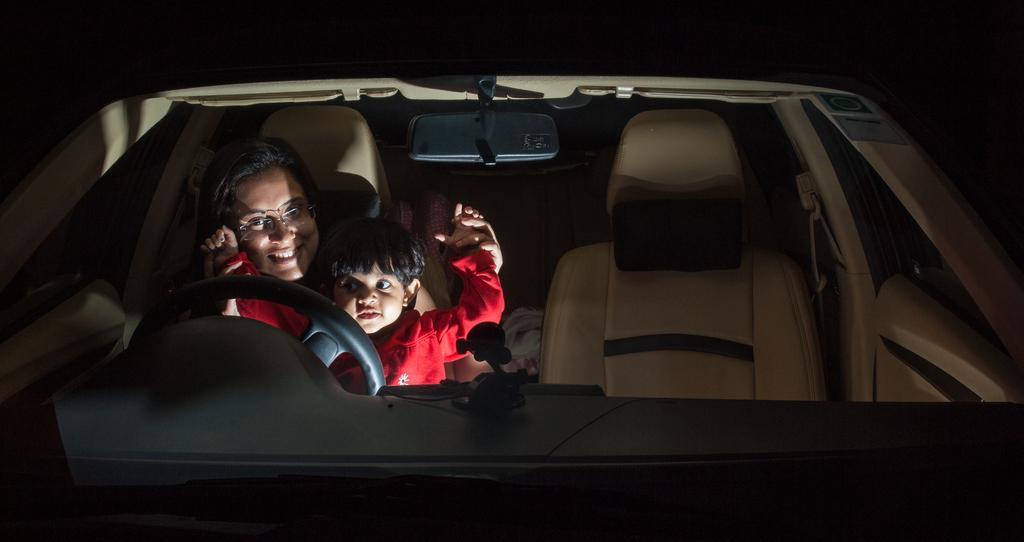In one or two sentences, can you explain what this image depicts? This is a car. One lady is sitting on the driving seat of this car. One child is sitting on the lap of the lady. Both of them are smiling. 